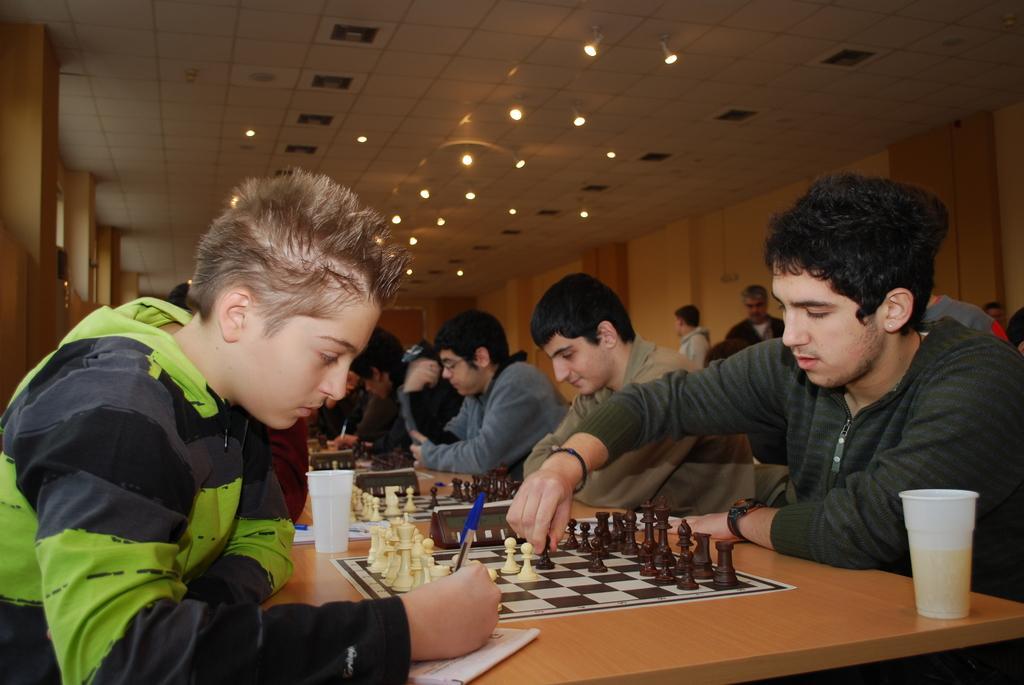Please provide a concise description of this image. Few persons sitting on the chair. These two persons standing. We can see table. On the table we can see chess board,cup,pen,paper. On the background we can see wall,On the top we can see lights. 